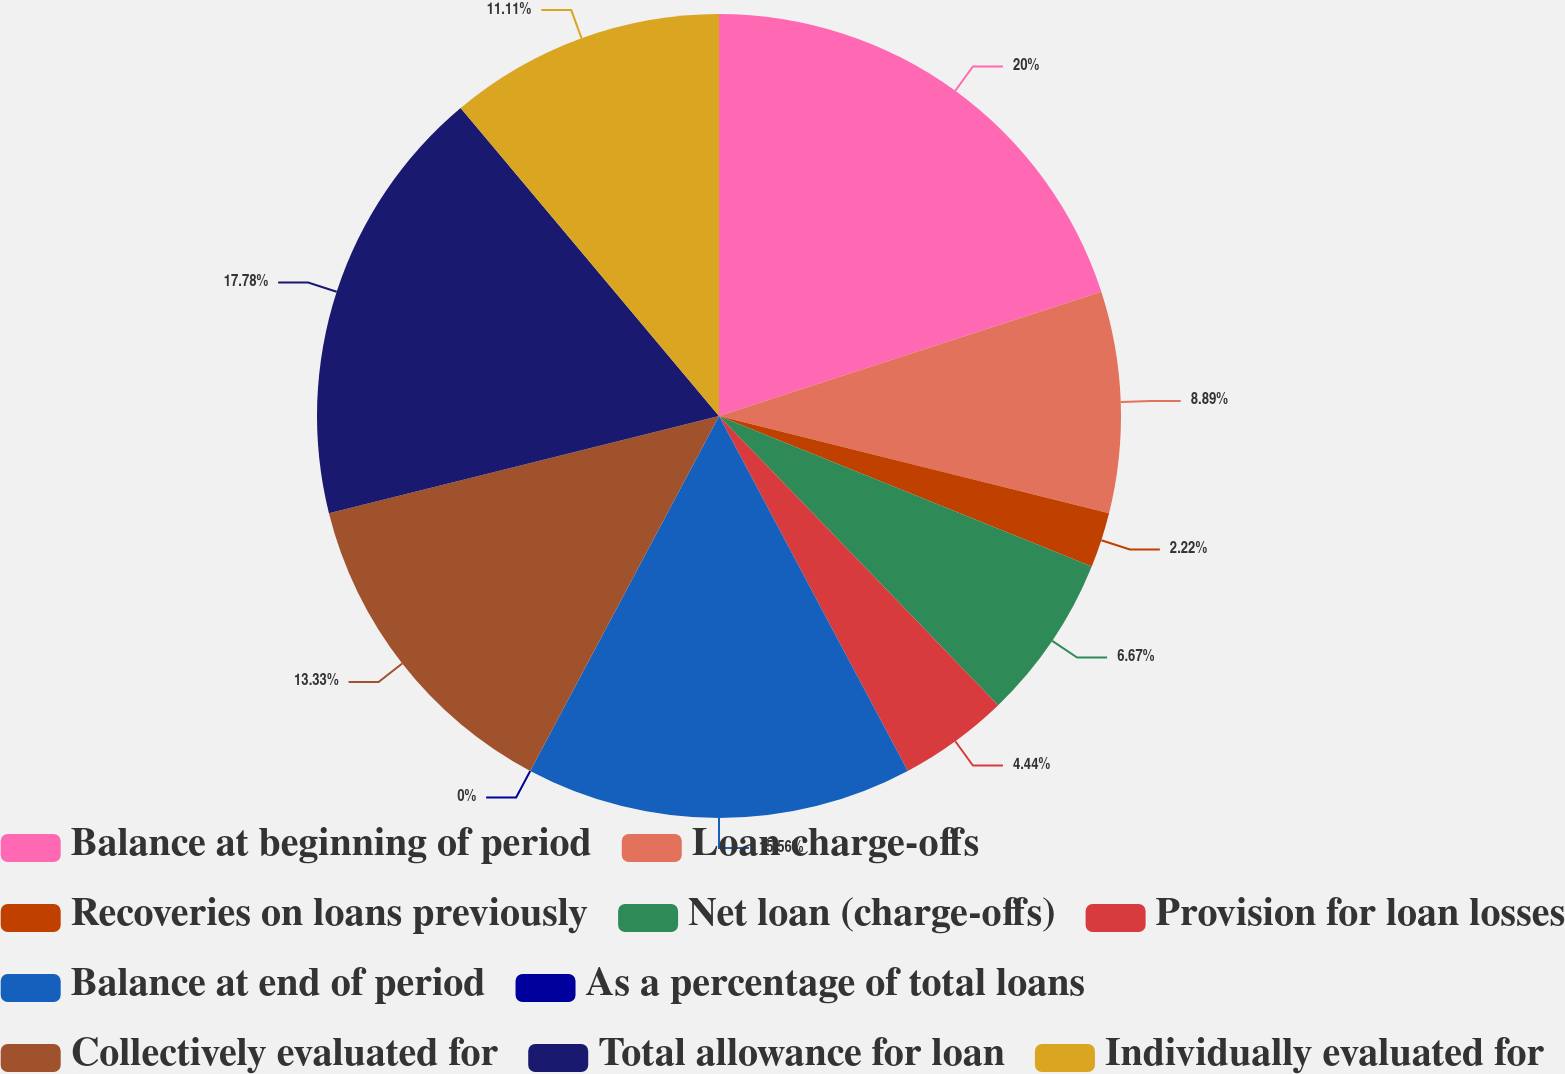Convert chart to OTSL. <chart><loc_0><loc_0><loc_500><loc_500><pie_chart><fcel>Balance at beginning of period<fcel>Loan charge-offs<fcel>Recoveries on loans previously<fcel>Net loan (charge-offs)<fcel>Provision for loan losses<fcel>Balance at end of period<fcel>As a percentage of total loans<fcel>Collectively evaluated for<fcel>Total allowance for loan<fcel>Individually evaluated for<nl><fcel>20.0%<fcel>8.89%<fcel>2.22%<fcel>6.67%<fcel>4.44%<fcel>15.56%<fcel>0.0%<fcel>13.33%<fcel>17.78%<fcel>11.11%<nl></chart> 